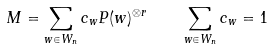Convert formula to latex. <formula><loc_0><loc_0><loc_500><loc_500>M = \sum _ { w \in W _ { n } } c _ { w } P ( w ) ^ { \otimes r } \quad \sum _ { w \in W _ { n } } c _ { w } = 1</formula> 